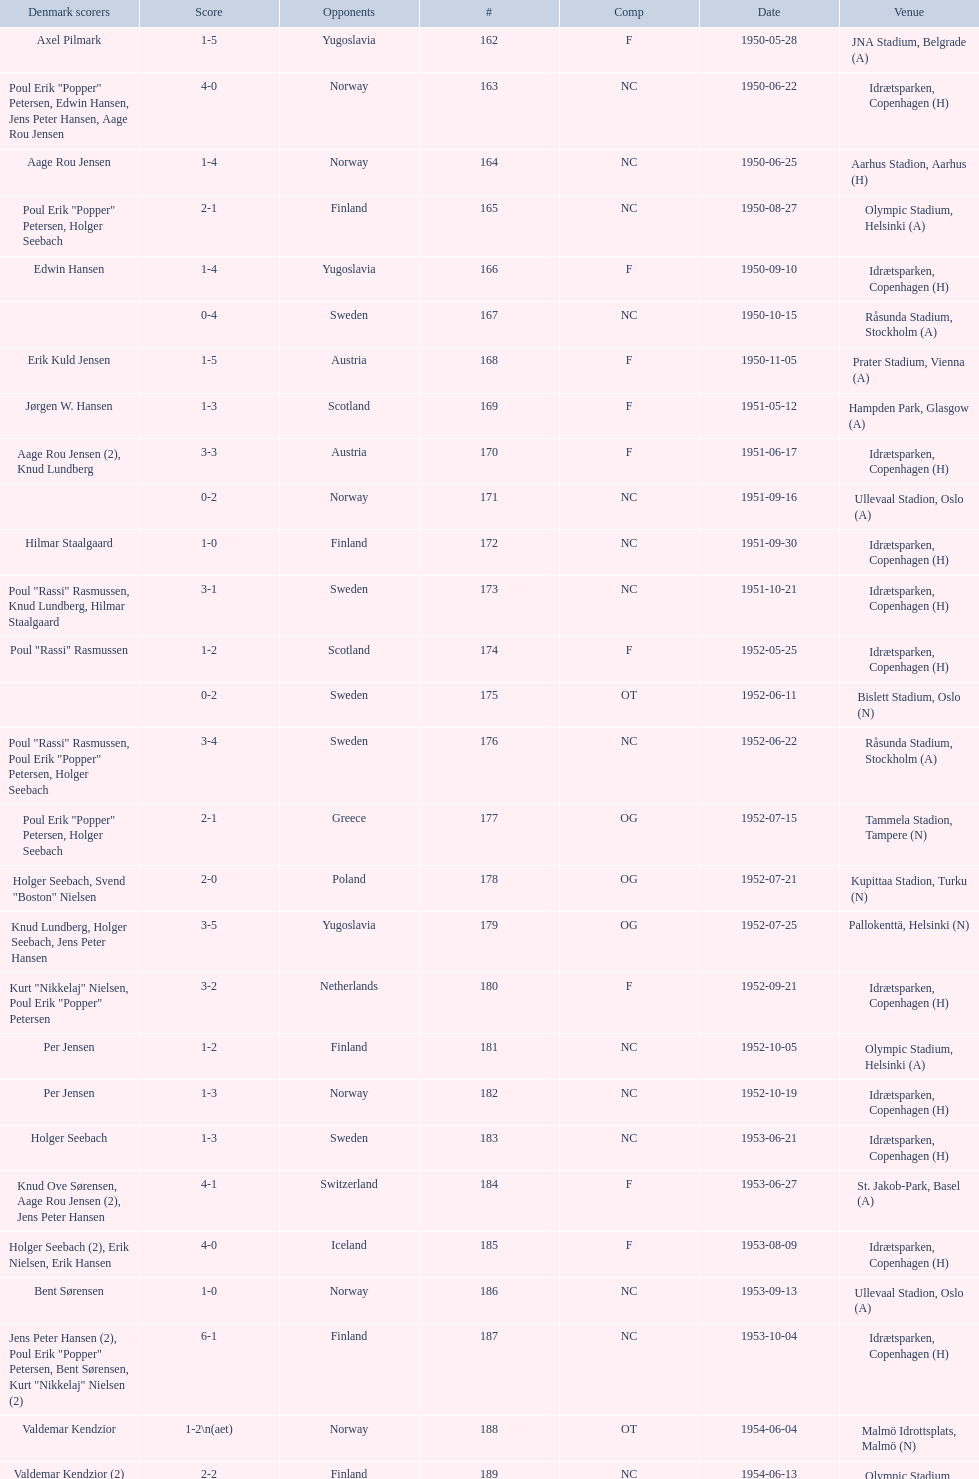What is the location directly beneath jna stadium, belgrade (a)? Idrætsparken, Copenhagen (H). 